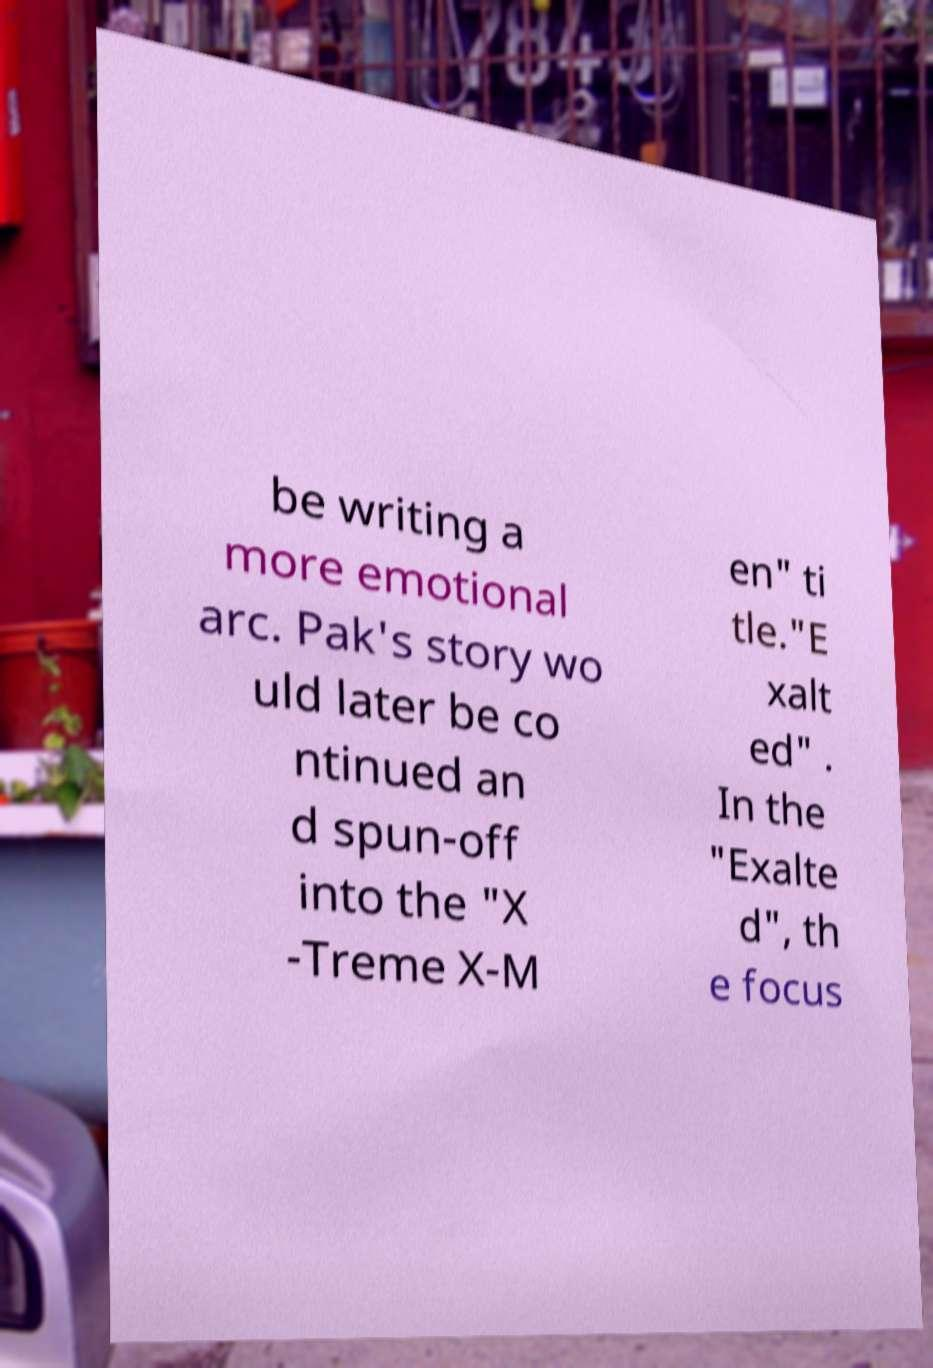Can you accurately transcribe the text from the provided image for me? be writing a more emotional arc. Pak's story wo uld later be co ntinued an d spun-off into the "X -Treme X-M en" ti tle."E xalt ed" . In the "Exalte d", th e focus 